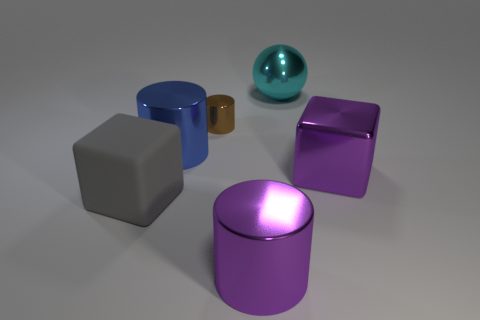Are there any small cylinders that have the same material as the cyan ball?
Keep it short and to the point. Yes. What material is the sphere that is the same size as the blue metallic cylinder?
Provide a short and direct response. Metal. There is a large block on the right side of the big shiny cylinder on the left side of the cylinder in front of the matte block; what is its color?
Provide a succinct answer. Purple. There is a small brown thing on the right side of the blue thing; does it have the same shape as the purple thing in front of the purple block?
Make the answer very short. Yes. What number of large red metallic objects are there?
Your response must be concise. 0. What color is the metallic cube that is the same size as the blue cylinder?
Ensure brevity in your answer.  Purple. Are the big block that is on the left side of the brown shiny object and the cylinder right of the tiny thing made of the same material?
Your answer should be compact. No. There is a cube that is on the left side of the purple metal object that is on the left side of the metallic sphere; how big is it?
Offer a very short reply. Large. There is a big purple object that is on the right side of the big cyan shiny ball; what material is it?
Give a very brief answer. Metal. What number of objects are either large metallic things that are behind the big gray matte cube or things in front of the big cyan shiny thing?
Provide a short and direct response. 6. 